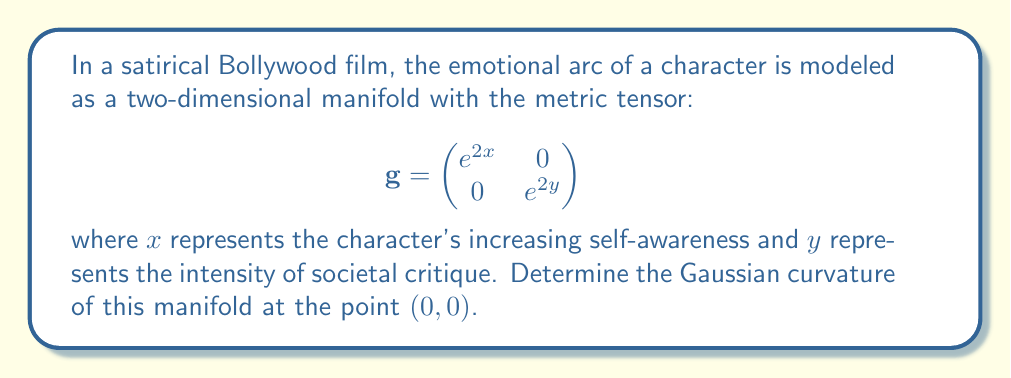Provide a solution to this math problem. To find the Gaussian curvature, we'll follow these steps:

1) The Gaussian curvature K is given by:
   $$K = \frac{R_{1212}}{det(g)}$$
   where $R_{1212}$ is a component of the Riemann curvature tensor.

2) To calculate $R_{1212}$, we need the Christoffel symbols. For a metric of the form:
   $$g_{ij} = \begin{pmatrix}
   A(x,y) & 0 \\
   0 & B(x,y)
   \end{pmatrix}$$
   The non-zero Christoffel symbols are:
   $$\Gamma^1_{11} = \frac{A_x}{2A}, \Gamma^1_{22} = -\frac{B_x}{2A}$$
   $$\Gamma^2_{12} = \frac{A_y}{2B}, \Gamma^2_{22} = \frac{B_y}{2B}$$

3) In our case, $A(x,y) = e^{2x}$ and $B(x,y) = e^{2y}$. So:
   $$\Gamma^1_{11} = 1, \Gamma^1_{22} = 0$$
   $$\Gamma^2_{12} = 0, \Gamma^2_{22} = 1$$

4) The Riemann curvature tensor component $R_{1212}$ is given by:
   $$R_{1212} = \frac{\partial \Gamma^1_{12}}{\partial y} - \frac{\partial \Gamma^1_{22}}{\partial x} + \Gamma^1_{1k}\Gamma^k_{22} - \Gamma^1_{2k}\Gamma^k_{12}$$

5) Substituting our Christoffel symbols:
   $$R_{1212} = 0 - 0 + \Gamma^1_{11}\Gamma^1_{22} + \Gamma^1_{12}\Gamma^2_{22} - 0 - 0 = 1 \cdot 0 + 0 \cdot 1 = 0$$

6) The determinant of the metric tensor is:
   $$det(g) = e^{2x} \cdot e^{2y} = e^{2(x+y)}$$

7) Therefore, the Gaussian curvature is:
   $$K = \frac{R_{1212}}{det(g)} = \frac{0}{e^{2(x+y)}} = 0$$

8) This result holds for all points on the manifold, including $(0,0)$.
Answer: $K = 0$ 